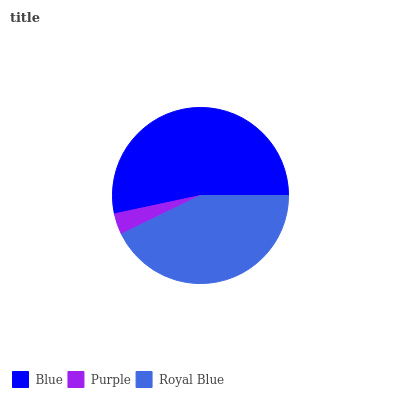Is Purple the minimum?
Answer yes or no. Yes. Is Blue the maximum?
Answer yes or no. Yes. Is Royal Blue the minimum?
Answer yes or no. No. Is Royal Blue the maximum?
Answer yes or no. No. Is Royal Blue greater than Purple?
Answer yes or no. Yes. Is Purple less than Royal Blue?
Answer yes or no. Yes. Is Purple greater than Royal Blue?
Answer yes or no. No. Is Royal Blue less than Purple?
Answer yes or no. No. Is Royal Blue the high median?
Answer yes or no. Yes. Is Royal Blue the low median?
Answer yes or no. Yes. Is Blue the high median?
Answer yes or no. No. Is Blue the low median?
Answer yes or no. No. 